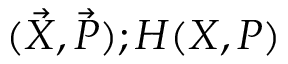<formula> <loc_0><loc_0><loc_500><loc_500>( \vec { X } , \vec { P } ) ; H ( X , P )</formula> 